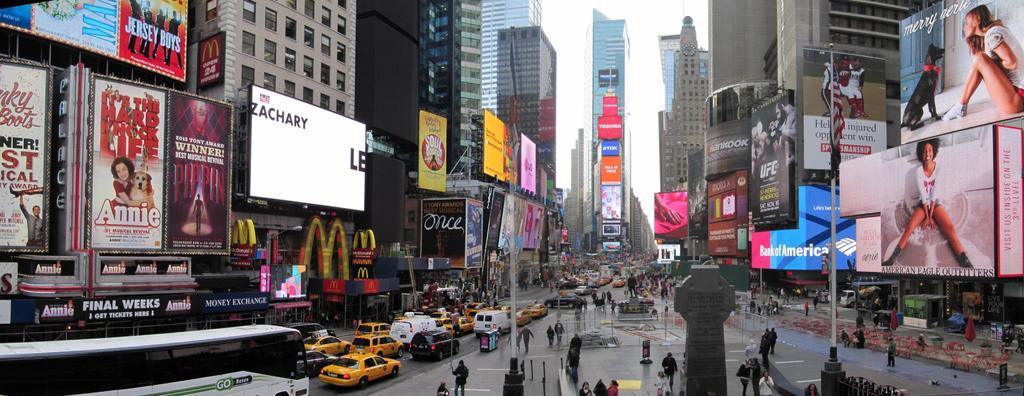Provide a one-sentence caption for the provided image. A busy street filled with large advertisements for the movie Annie. 